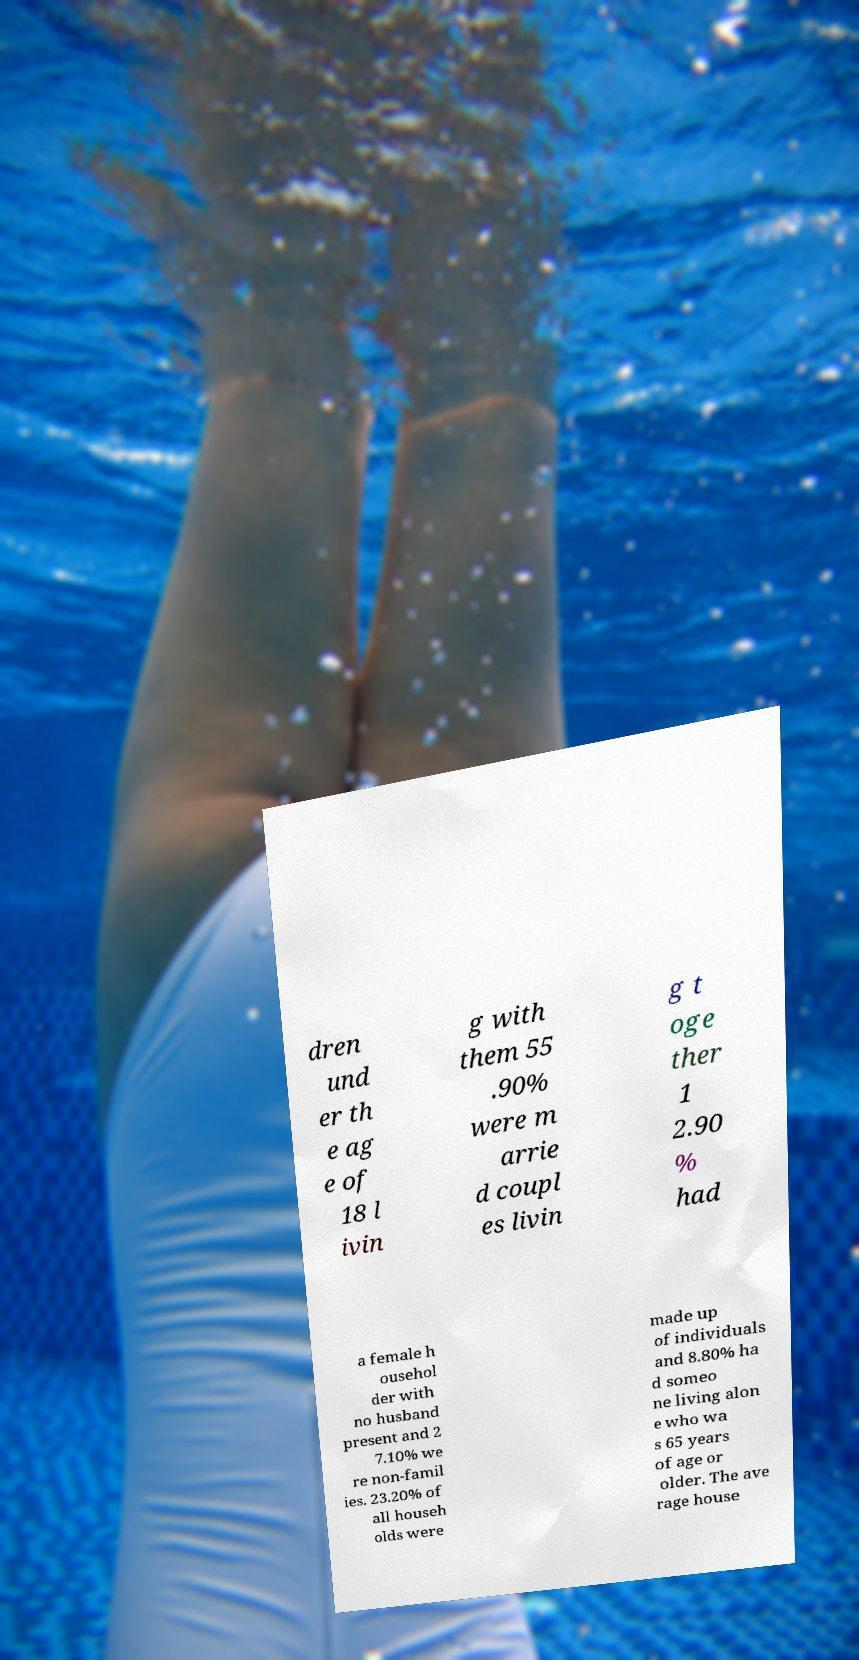For documentation purposes, I need the text within this image transcribed. Could you provide that? dren und er th e ag e of 18 l ivin g with them 55 .90% were m arrie d coupl es livin g t oge ther 1 2.90 % had a female h ousehol der with no husband present and 2 7.10% we re non-famil ies. 23.20% of all househ olds were made up of individuals and 8.80% ha d someo ne living alon e who wa s 65 years of age or older. The ave rage house 